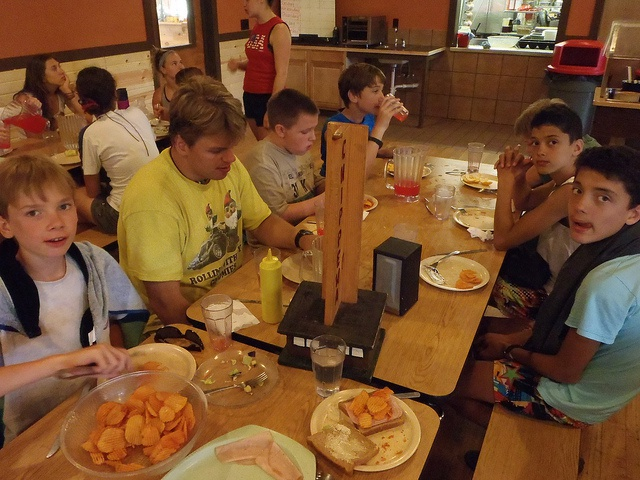Describe the objects in this image and their specific colors. I can see dining table in brown, tan, and gray tones, people in brown, black, maroon, and gray tones, people in brown, maroon, black, and darkgray tones, dining table in brown, olive, maroon, and tan tones, and people in brown, olive, maroon, and tan tones in this image. 